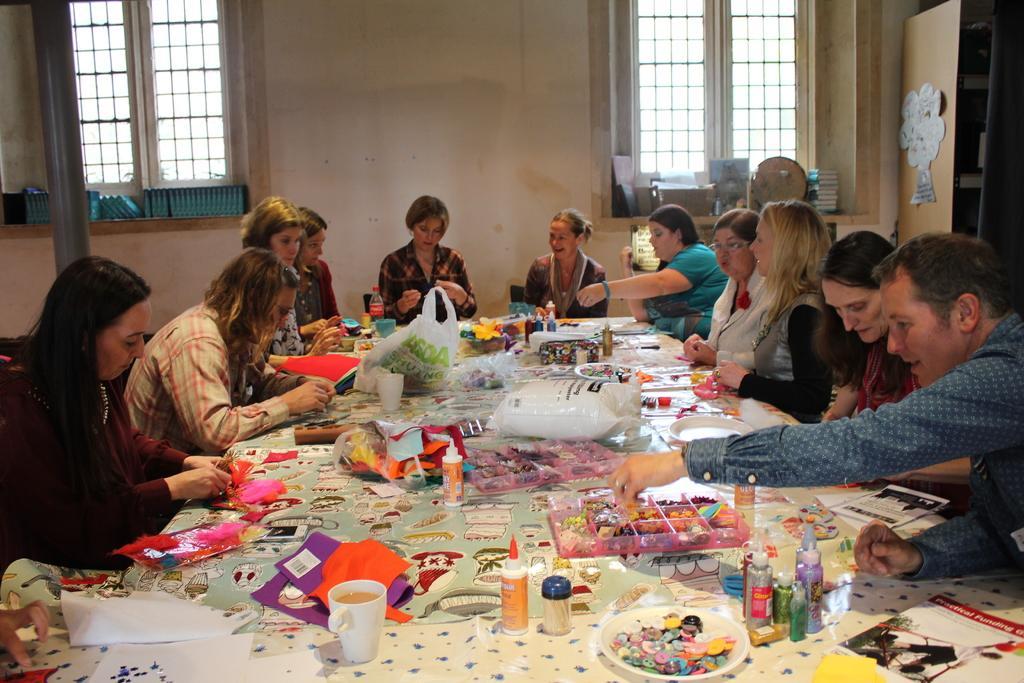Could you give a brief overview of what you see in this image? In this picture we can see a few cups, bottles, carry bags, plates and decorative items on the table. We can see some a group of people sitting on the chair from left to right. There are books, boxes and some blue objects are visible on the shelves. We can see the windows and a wall in the background. 